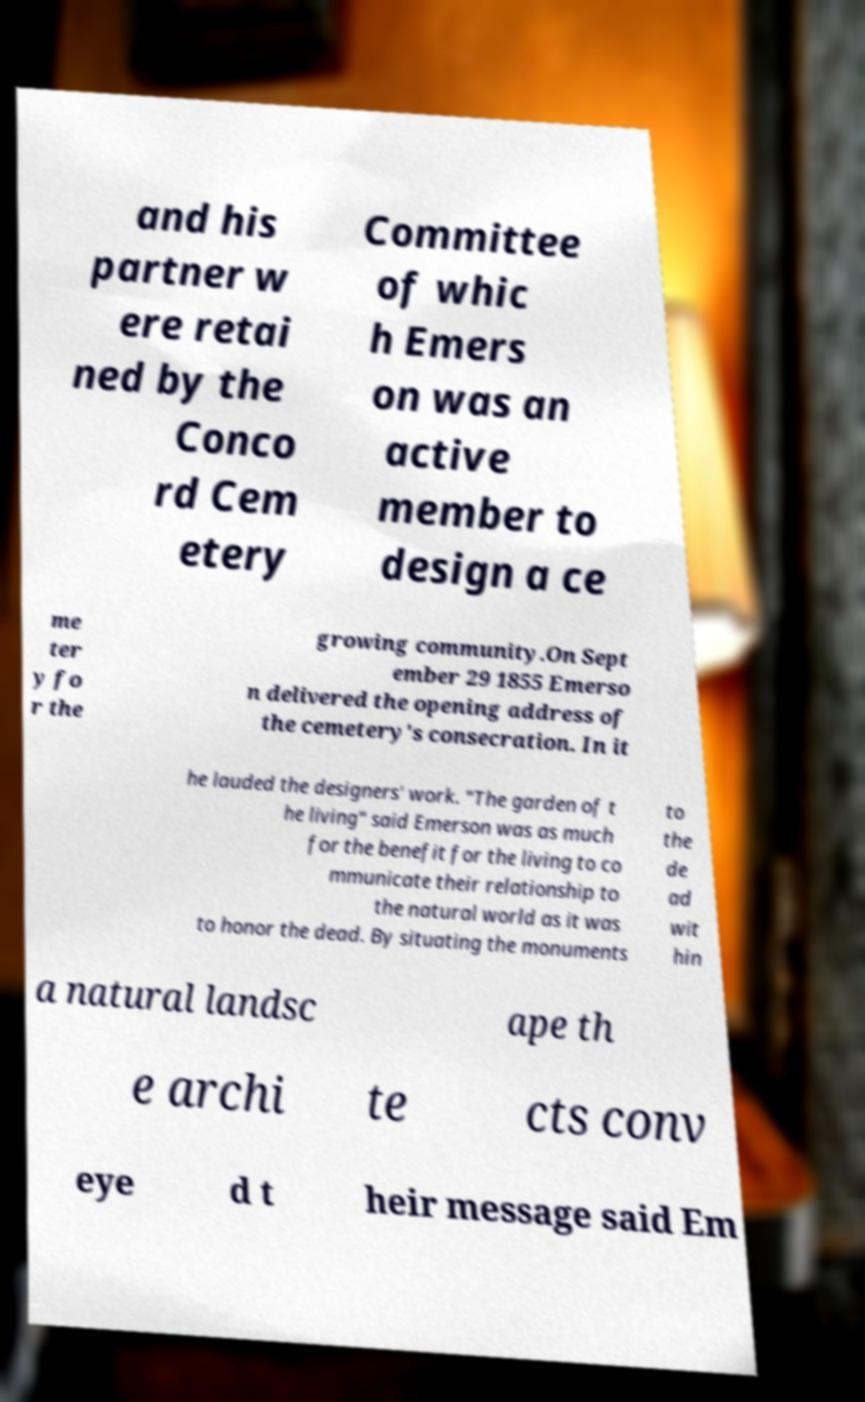Could you assist in decoding the text presented in this image and type it out clearly? and his partner w ere retai ned by the Conco rd Cem etery Committee of whic h Emers on was an active member to design a ce me ter y fo r the growing community.On Sept ember 29 1855 Emerso n delivered the opening address of the cemetery's consecration. In it he lauded the designers' work. "The garden of t he living" said Emerson was as much for the benefit for the living to co mmunicate their relationship to the natural world as it was to honor the dead. By situating the monuments to the de ad wit hin a natural landsc ape th e archi te cts conv eye d t heir message said Em 